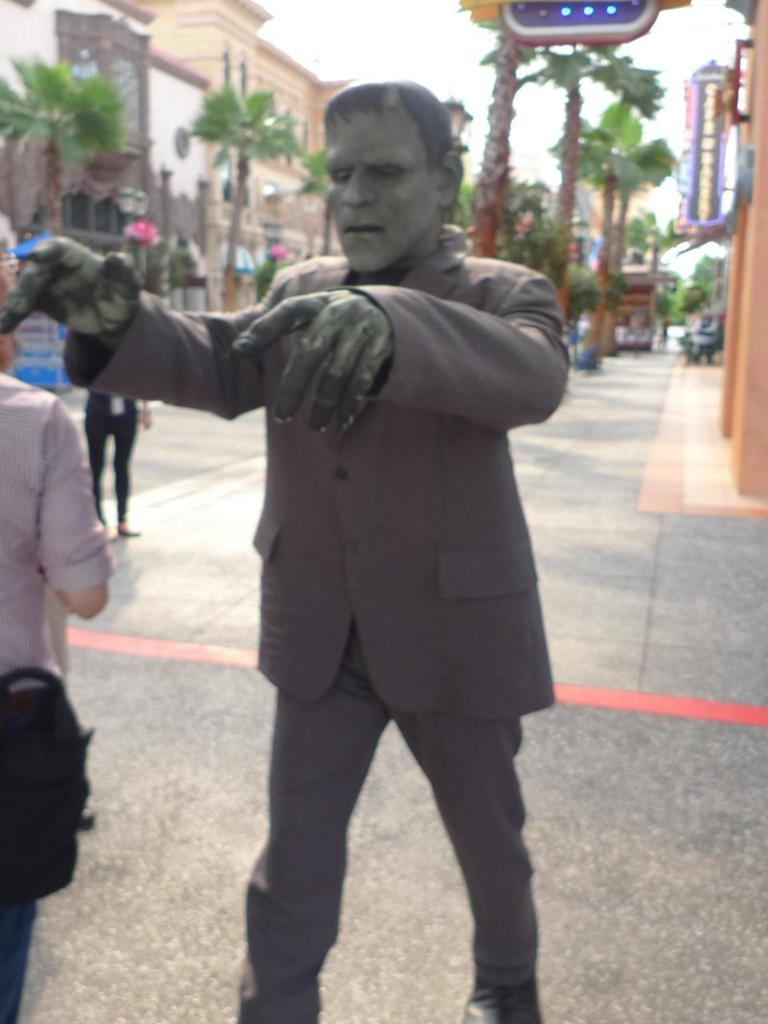What is the main subject in the image? There is a statue in the image. Are there any people present in the image? Yes, there are two people in the image. What can be seen in the background of the image? There are trees, buildings, and the sky visible in the background of the image. How does the son interact with the statue in the image? There is no son present in the image, so it is not possible to answer that question. 